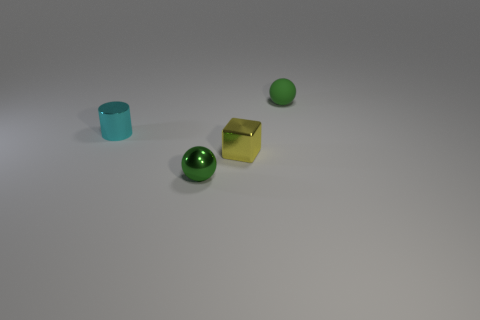How many things are tiny yellow metal blocks or green metal spheres? In the image, there is one tiny yellow metal block and two green metal spheres, making a total of three objects that match the description. 